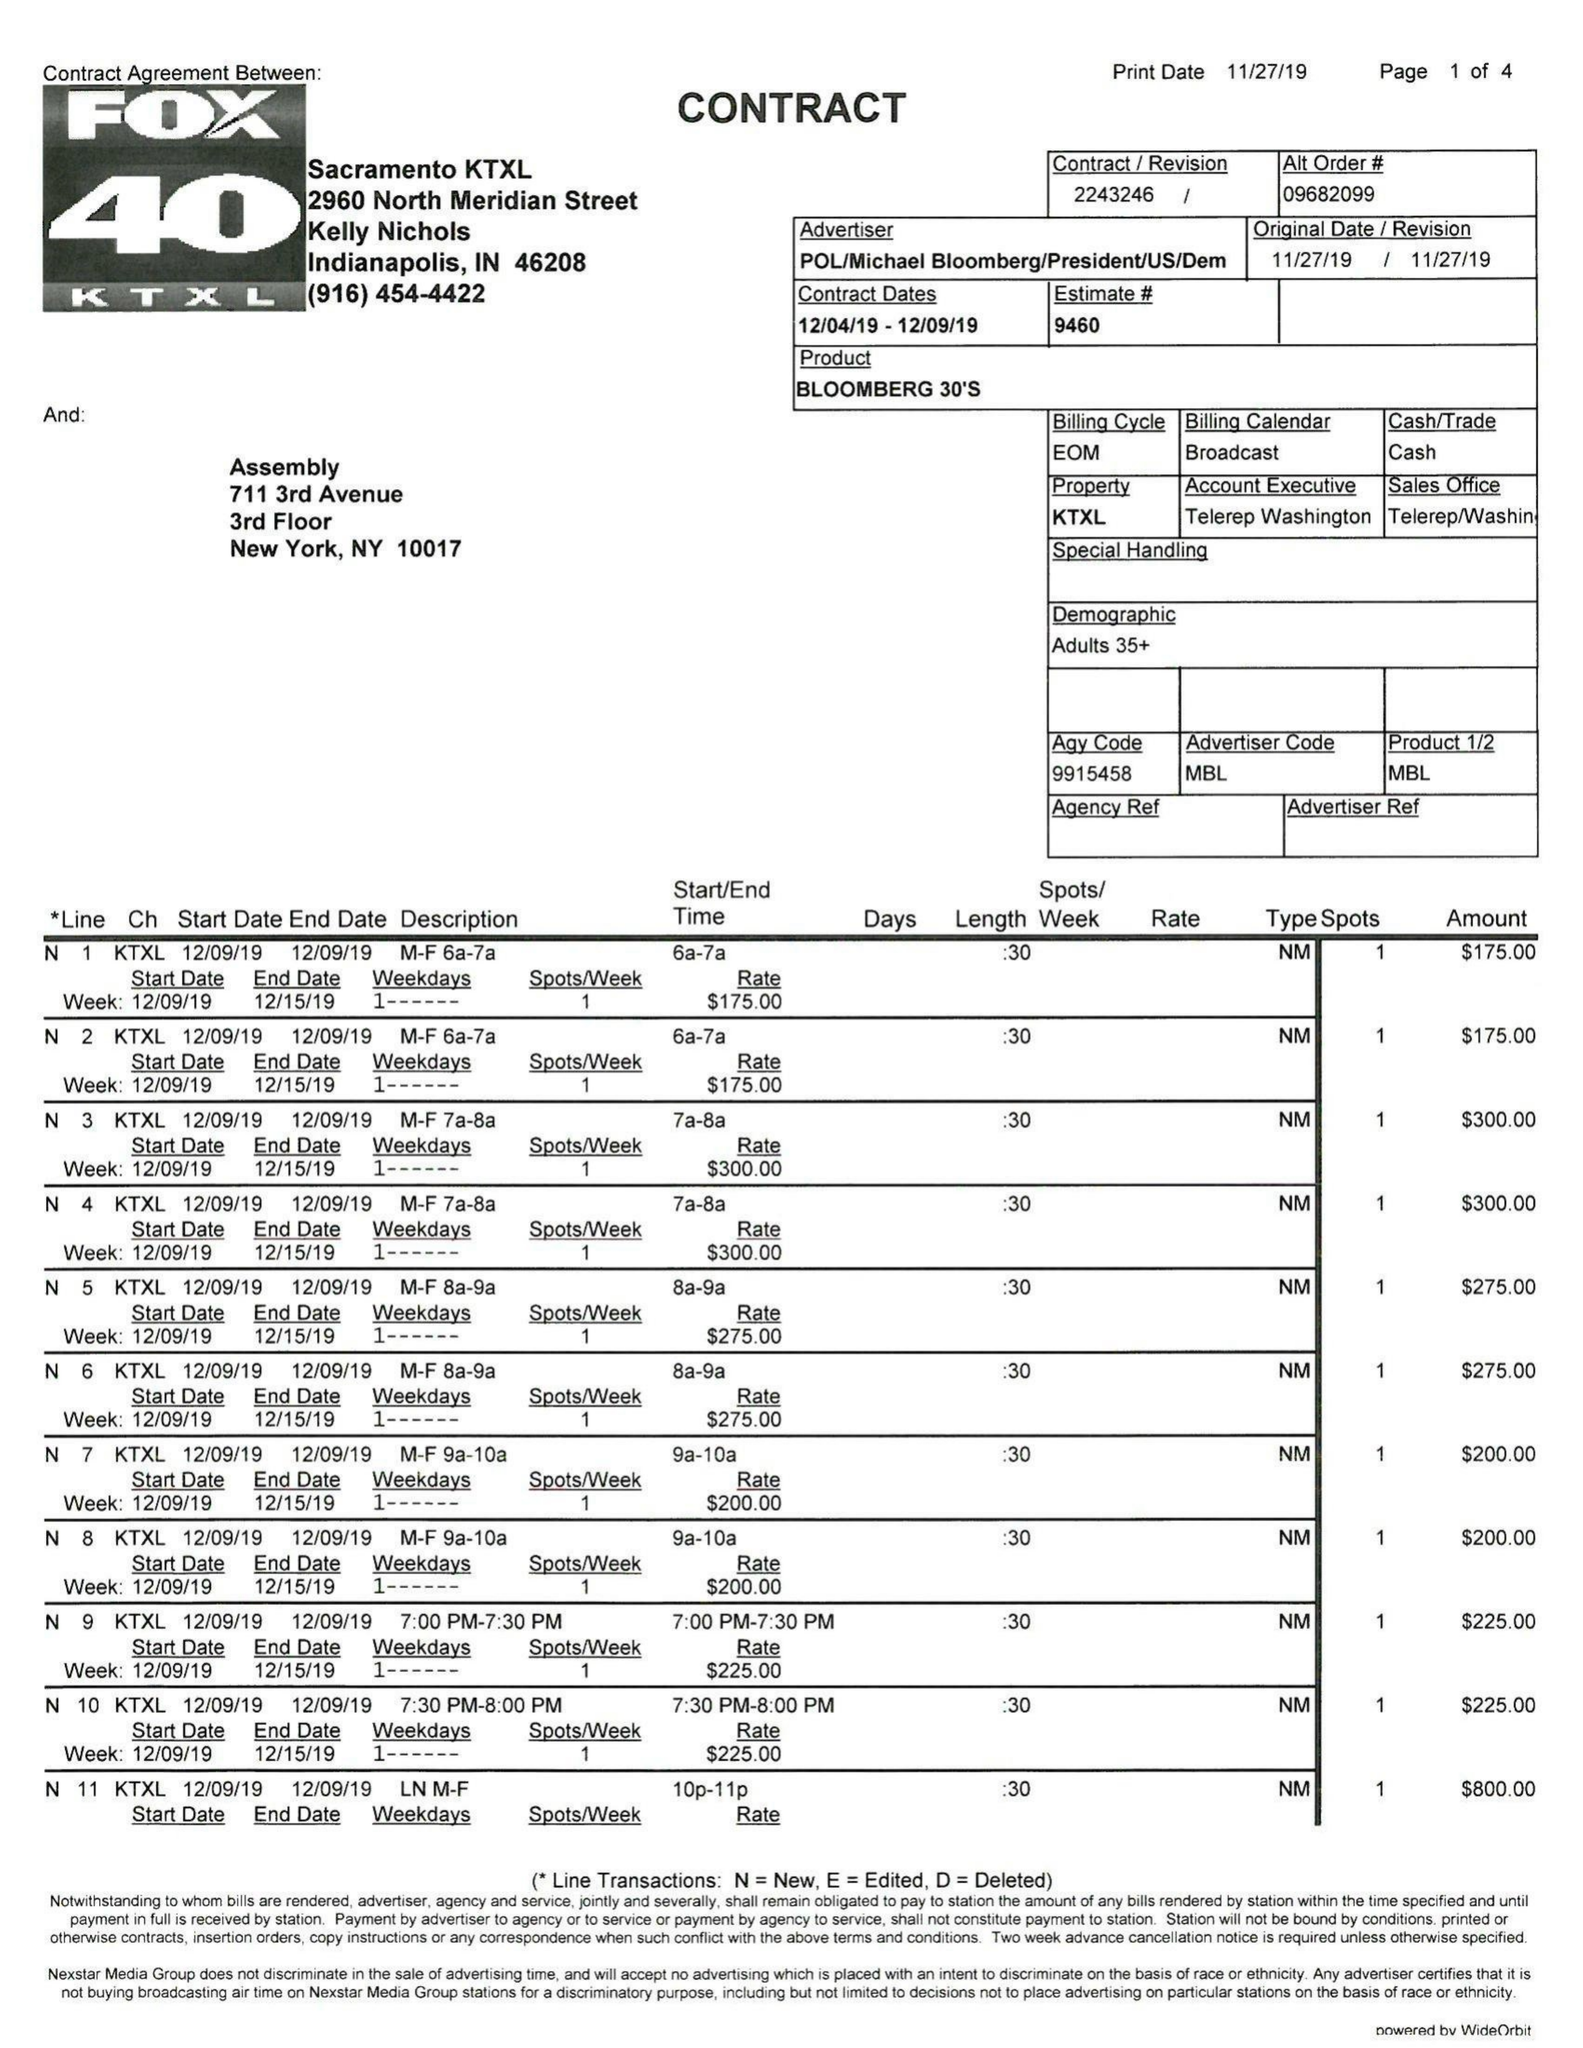What is the value for the gross_amount?
Answer the question using a single word or phrase. 74625.00 